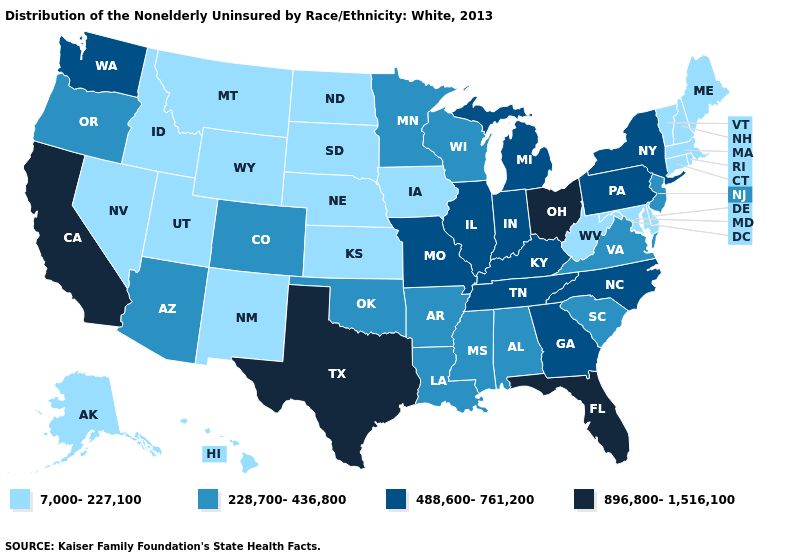Among the states that border Wisconsin , which have the highest value?
Quick response, please. Illinois, Michigan. What is the value of Iowa?
Quick response, please. 7,000-227,100. What is the lowest value in the MidWest?
Concise answer only. 7,000-227,100. What is the value of Alaska?
Write a very short answer. 7,000-227,100. Among the states that border Arkansas , which have the highest value?
Concise answer only. Texas. Name the states that have a value in the range 488,600-761,200?
Quick response, please. Georgia, Illinois, Indiana, Kentucky, Michigan, Missouri, New York, North Carolina, Pennsylvania, Tennessee, Washington. What is the value of Louisiana?
Answer briefly. 228,700-436,800. Does Tennessee have a higher value than Illinois?
Short answer required. No. Which states have the highest value in the USA?
Write a very short answer. California, Florida, Ohio, Texas. What is the value of Nevada?
Keep it brief. 7,000-227,100. Among the states that border New Jersey , which have the lowest value?
Concise answer only. Delaware. What is the value of Kansas?
Concise answer only. 7,000-227,100. Among the states that border Arkansas , which have the highest value?
Be succinct. Texas. Does Maine have the lowest value in the Northeast?
Write a very short answer. Yes. Does South Dakota have the lowest value in the MidWest?
Be succinct. Yes. 